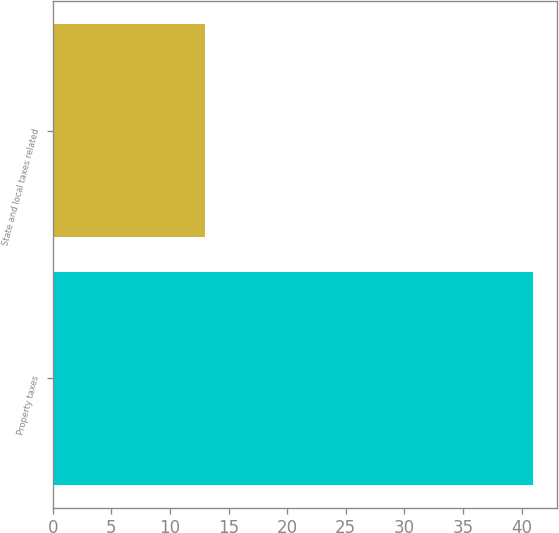Convert chart. <chart><loc_0><loc_0><loc_500><loc_500><bar_chart><fcel>Property taxes<fcel>State and local taxes related<nl><fcel>41<fcel>13<nl></chart> 